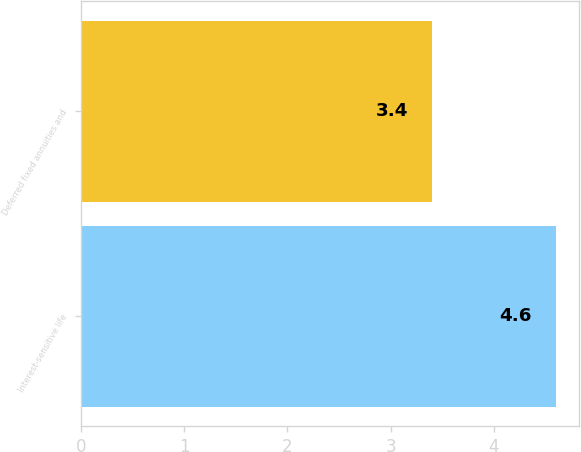<chart> <loc_0><loc_0><loc_500><loc_500><bar_chart><fcel>Interest-sensitive life<fcel>Deferred fixed annuities and<nl><fcel>4.6<fcel>3.4<nl></chart> 